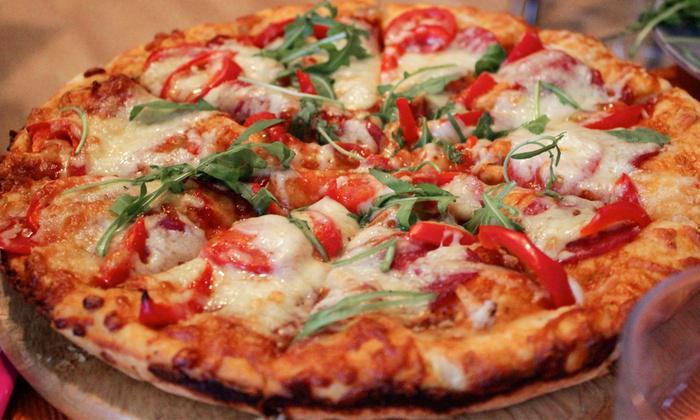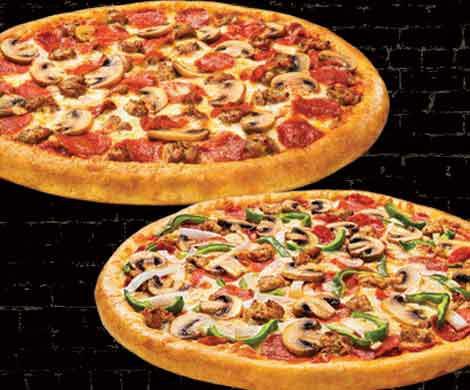The first image is the image on the left, the second image is the image on the right. Assess this claim about the two images: "One image contains two pizzas and the other image contains one pizza.". Correct or not? Answer yes or no. Yes. 